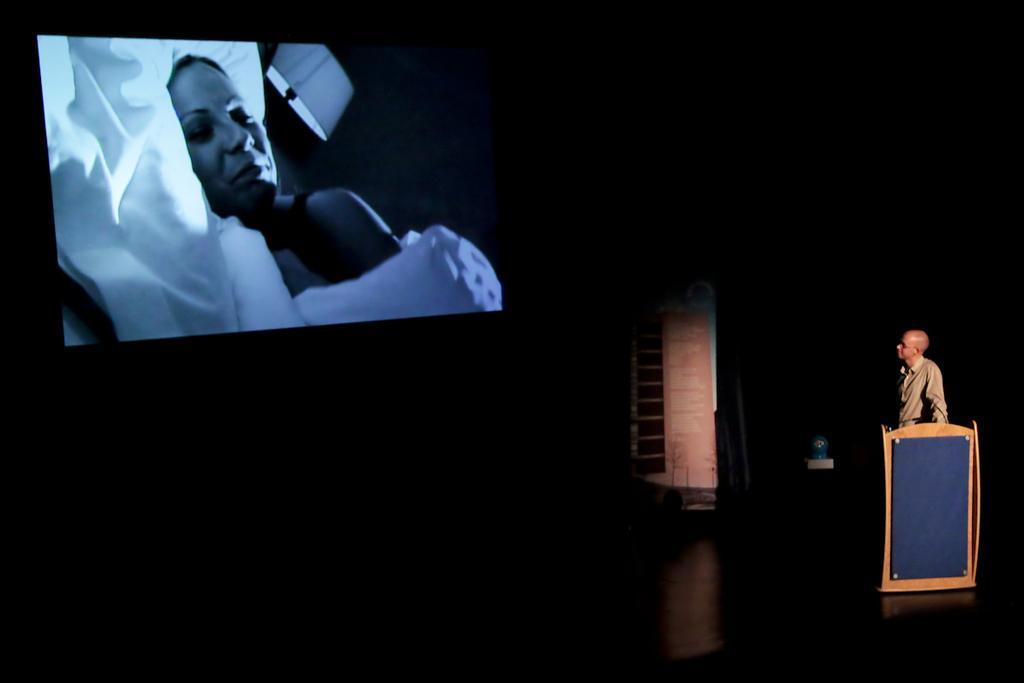In one or two sentences, can you explain what this image depicts? In this image I can see a man is standing. Here I can see a podium. I can also see a screen over here and on this screen I can see a woman and a lamp. I can also see this image is little bit in dark. 